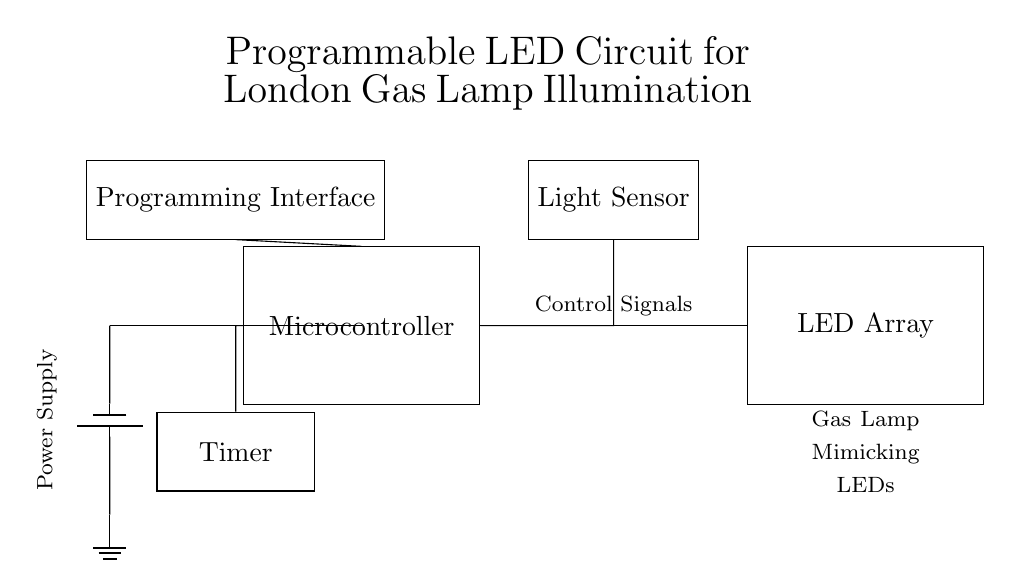What is the main component used to control the LED array? The main component is the microcontroller, which serves as the controller for the circuit and manages the operation of the LED array based on input signals and programming.
Answer: Microcontroller What type of sensor is included in the circuit? The circuit includes a light sensor, which detects ambient light levels and can provide feedback to the microcontroller to adjust the LED brightness accordingly.
Answer: Light sensor How many additional components are connected to the microcontroller? There are three additional components connected to the microcontroller: a programming interface, a timer, and a light sensor. This shows how multiple components interact with the microcontroller to manage the LED operations.
Answer: Three What is the purpose of the timer in this circuit? The timer's purpose is to periodically trigger events in the microcontroller, allowing for timed operations of the LED array, such as simulating the flickering pattern of gas lamps over time.
Answer: Timed operations Where does the power supply connect in the circuit? The power supply connects to the microcontroller and provides the necessary voltage to power the entire circuit, ensuring that the microcontroller and other components have the energy needed to function.
Answer: To the microcontroller What is the function of the programming interface? The programming interface allows users to input the desired illumination patterns and control logic into the microcontroller, thereby enabling customization of the LED behavior to mimic gas lamp lighting styles effectively.
Answer: Customize LED behavior 